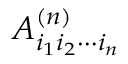<formula> <loc_0><loc_0><loc_500><loc_500>A _ { i _ { 1 } i _ { 2 } \cdots i _ { n } } ^ { ( n ) }</formula> 